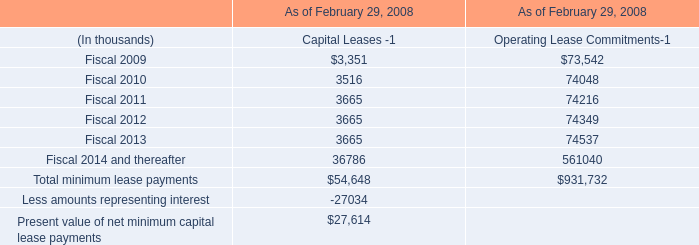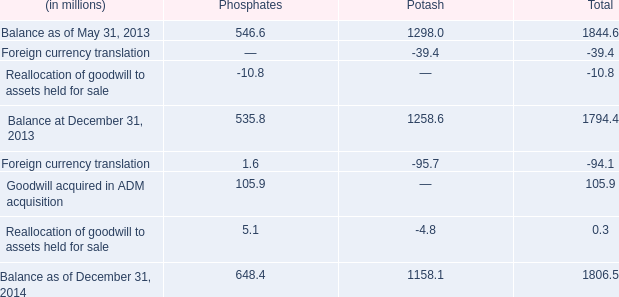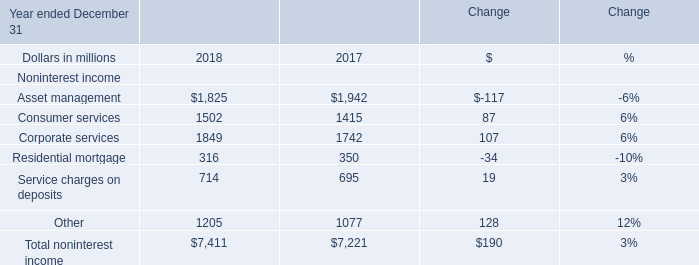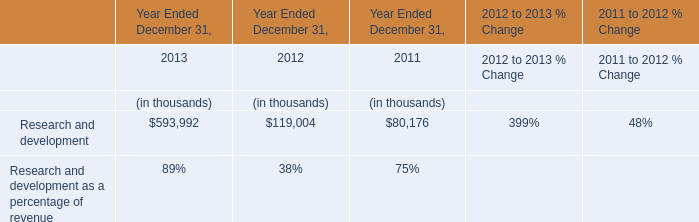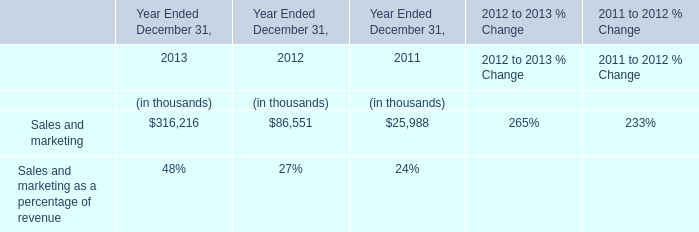What is the difference between the greatest consumer services in 2018 and 2017？ (in million) 
Computations: (1502 - 1415)
Answer: 87.0. 